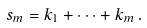Convert formula to latex. <formula><loc_0><loc_0><loc_500><loc_500>s _ { m } = k _ { 1 } + \dots + k _ { m } \, .</formula> 